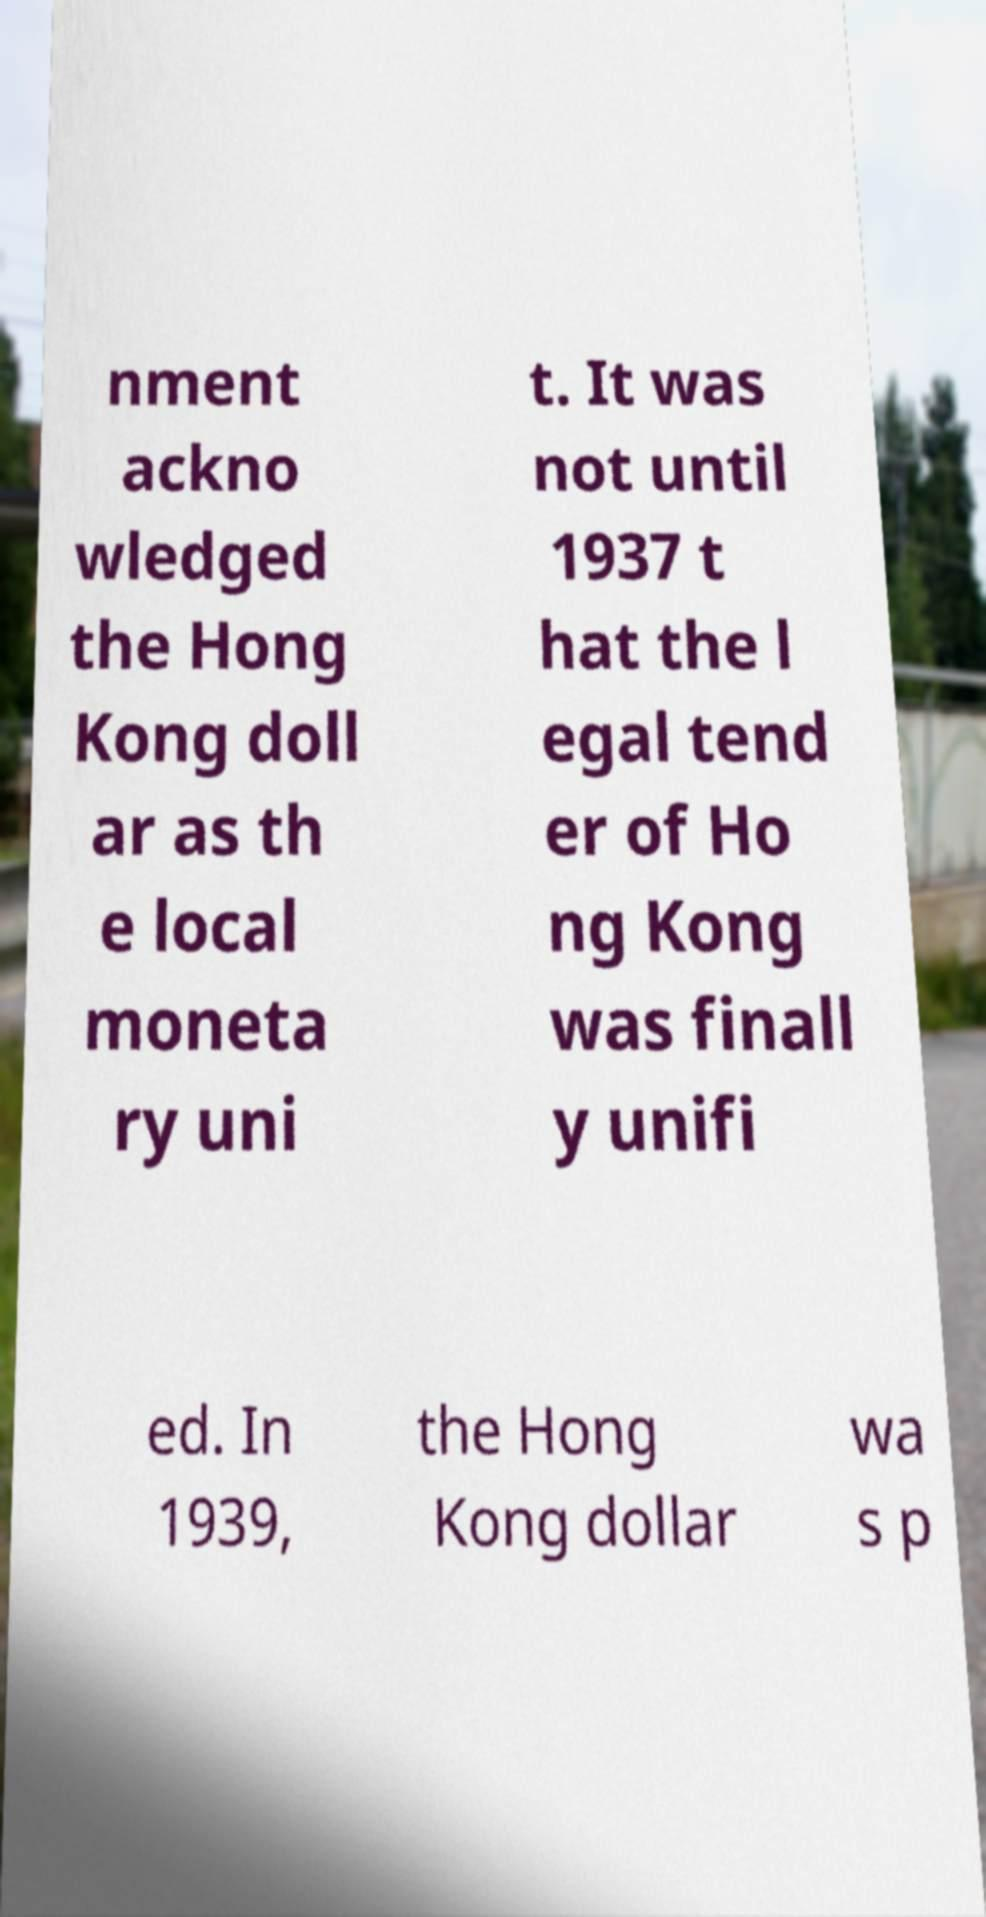There's text embedded in this image that I need extracted. Can you transcribe it verbatim? nment ackno wledged the Hong Kong doll ar as th e local moneta ry uni t. It was not until 1937 t hat the l egal tend er of Ho ng Kong was finall y unifi ed. In 1939, the Hong Kong dollar wa s p 